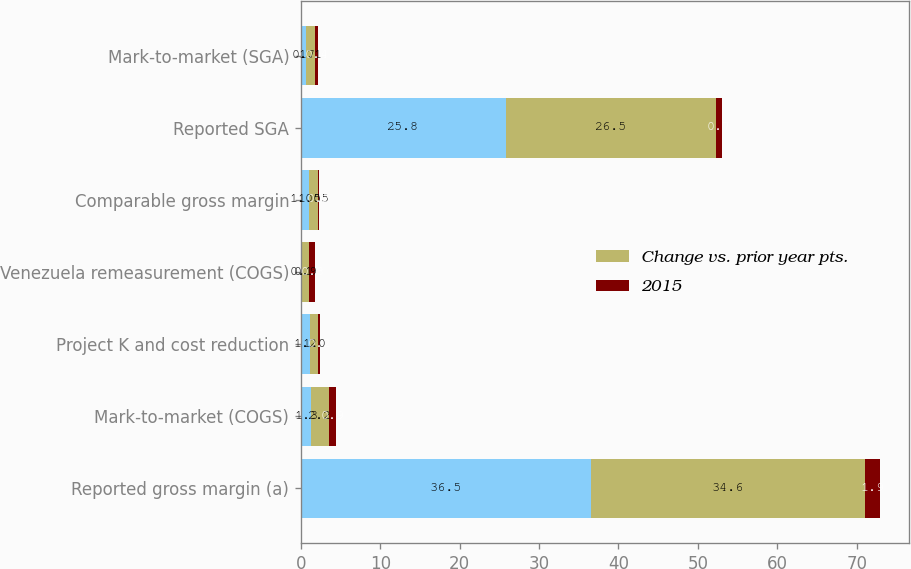Convert chart to OTSL. <chart><loc_0><loc_0><loc_500><loc_500><stacked_bar_chart><ecel><fcel>Reported gross margin (a)<fcel>Mark-to-market (COGS)<fcel>Project K and cost reduction<fcel>Venezuela remeasurement (COGS)<fcel>Comparable gross margin<fcel>Reported SGA<fcel>Mark-to-market (SGA)<nl><fcel>nan<fcel>36.5<fcel>1.3<fcel>1.2<fcel>0.1<fcel>1.05<fcel>25.8<fcel>0.7<nl><fcel>Change vs. prior year pts.<fcel>34.6<fcel>2.2<fcel>1<fcel>0.9<fcel>1.05<fcel>26.5<fcel>1.1<nl><fcel>2015<fcel>1.9<fcel>0.9<fcel>0.2<fcel>0.8<fcel>0.2<fcel>0.7<fcel>0.4<nl></chart> 